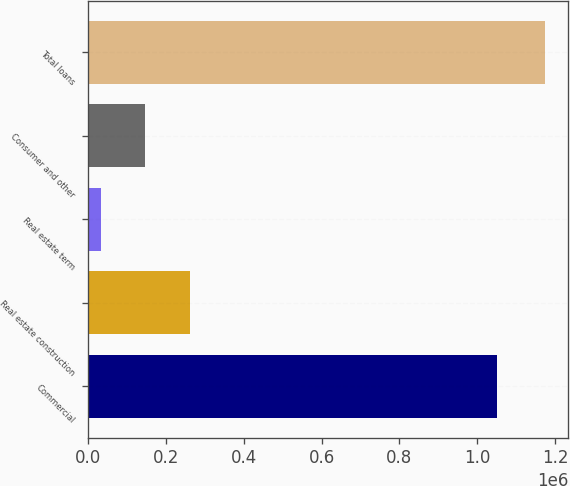Convert chart. <chart><loc_0><loc_0><loc_500><loc_500><bar_chart><fcel>Commercial<fcel>Real estate construction<fcel>Real estate term<fcel>Consumer and other<fcel>Total loans<nl><fcel>1.05122e+06<fcel>261645<fcel>33395<fcel>147520<fcel>1.17464e+06<nl></chart> 